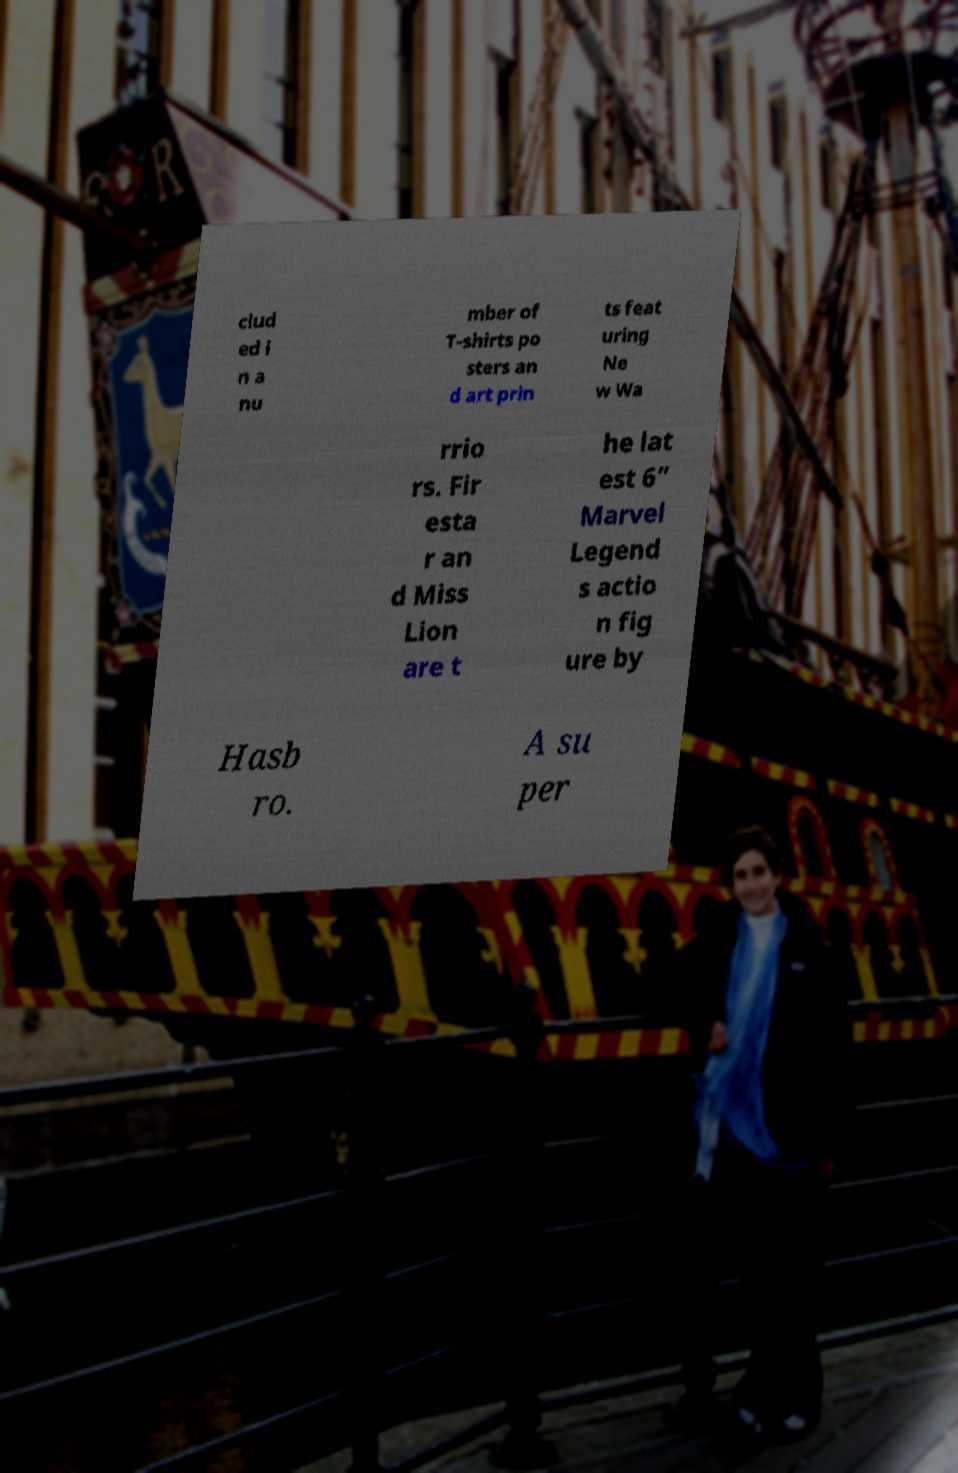Could you assist in decoding the text presented in this image and type it out clearly? clud ed i n a nu mber of T-shirts po sters an d art prin ts feat uring Ne w Wa rrio rs. Fir esta r an d Miss Lion are t he lat est 6” Marvel Legend s actio n fig ure by Hasb ro. A su per 